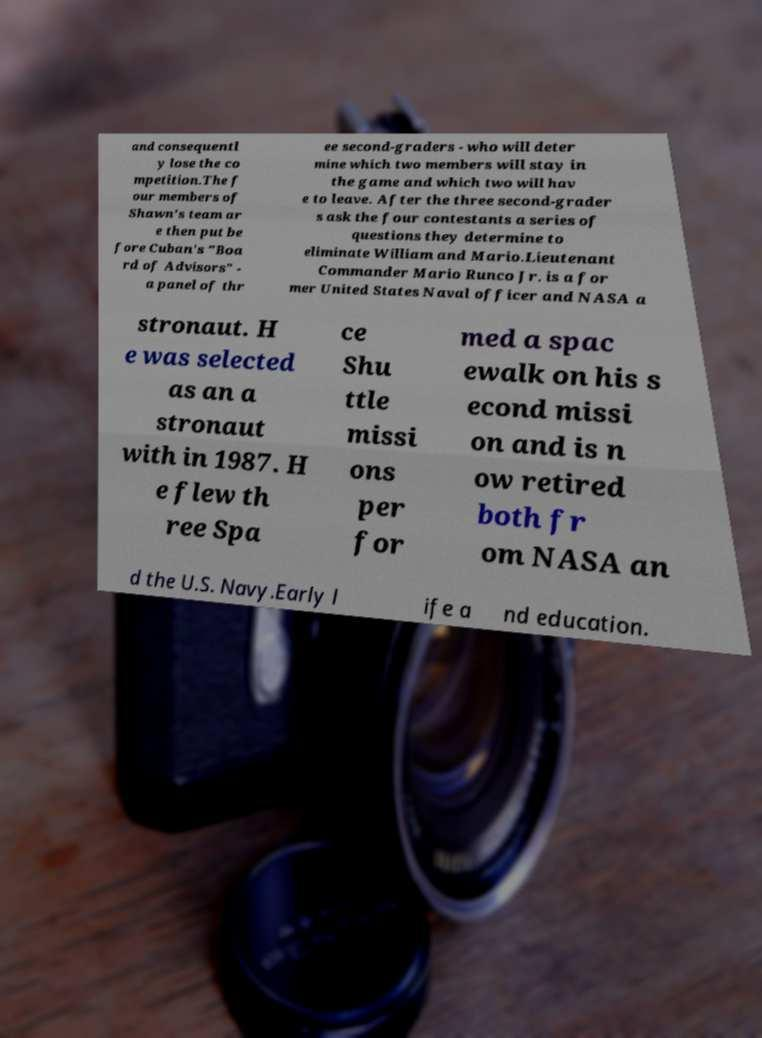I need the written content from this picture converted into text. Can you do that? and consequentl y lose the co mpetition.The f our members of Shawn's team ar e then put be fore Cuban's "Boa rd of Advisors" - a panel of thr ee second-graders - who will deter mine which two members will stay in the game and which two will hav e to leave. After the three second-grader s ask the four contestants a series of questions they determine to eliminate William and Mario.Lieutenant Commander Mario Runco Jr. is a for mer United States Naval officer and NASA a stronaut. H e was selected as an a stronaut with in 1987. H e flew th ree Spa ce Shu ttle missi ons per for med a spac ewalk on his s econd missi on and is n ow retired both fr om NASA an d the U.S. Navy.Early l ife a nd education. 